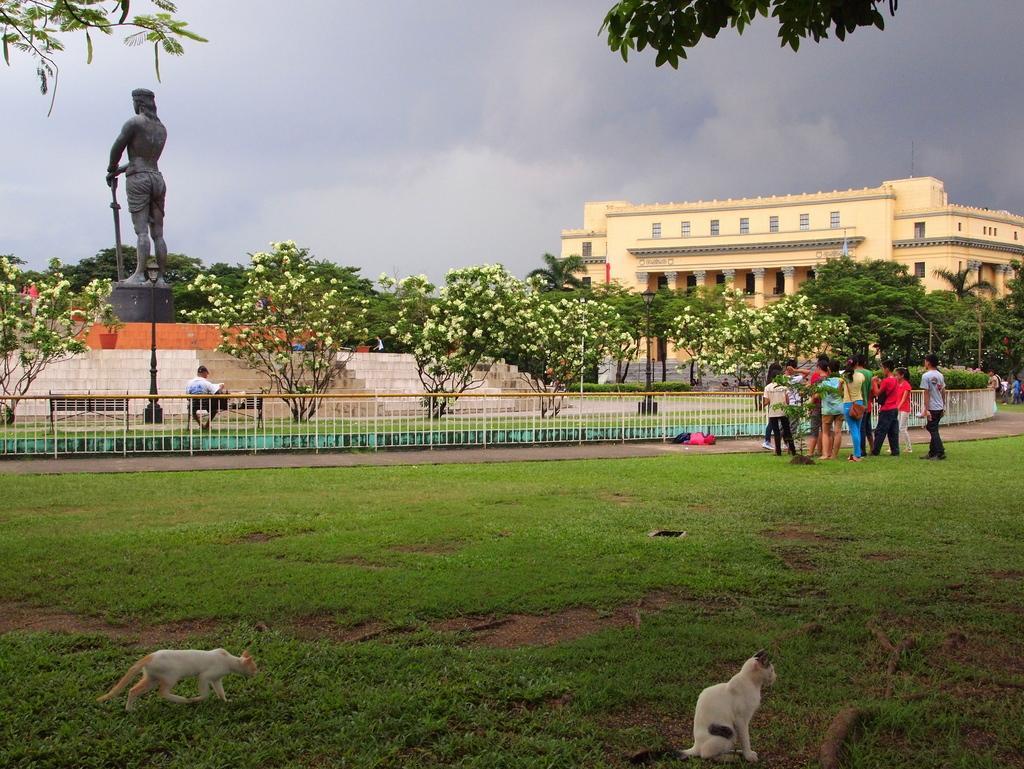Could you give a brief overview of what you see in this image? This picture describes about group of people, and we can see few cats on the grass, in the background we can see fence, trees, statue and a building, and also we can see few flowers. 